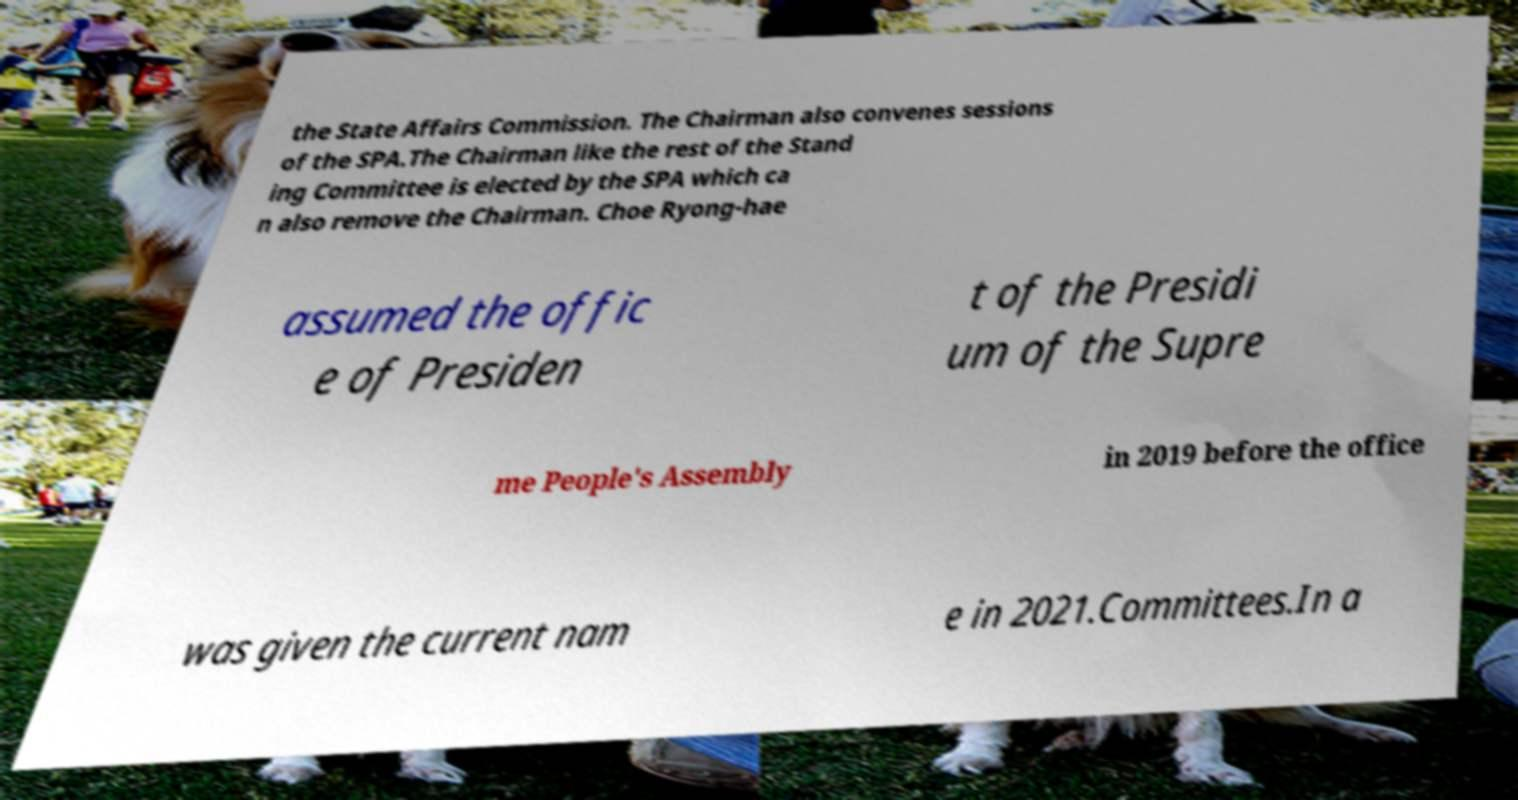Please read and relay the text visible in this image. What does it say? the State Affairs Commission. The Chairman also convenes sessions of the SPA.The Chairman like the rest of the Stand ing Committee is elected by the SPA which ca n also remove the Chairman. Choe Ryong-hae assumed the offic e of Presiden t of the Presidi um of the Supre me People's Assembly in 2019 before the office was given the current nam e in 2021.Committees.In a 